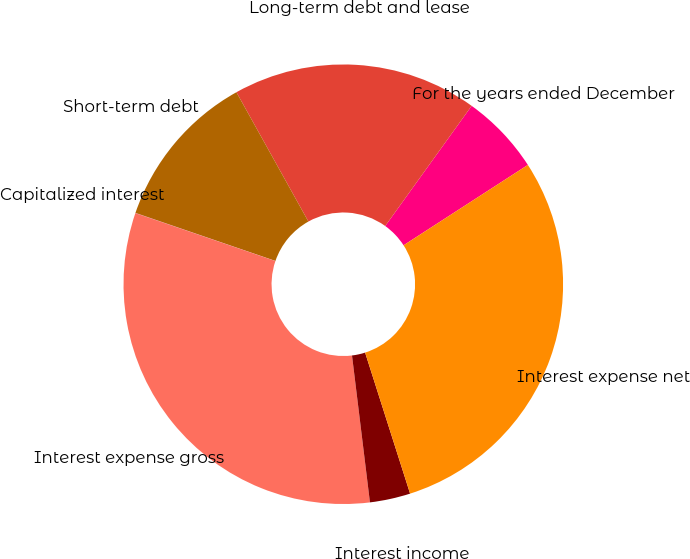<chart> <loc_0><loc_0><loc_500><loc_500><pie_chart><fcel>For the years ended December<fcel>Long-term debt and lease<fcel>Short-term debt<fcel>Capitalized interest<fcel>Interest expense gross<fcel>Interest income<fcel>Interest expense net<nl><fcel>5.94%<fcel>18.01%<fcel>11.65%<fcel>0.02%<fcel>32.18%<fcel>2.98%<fcel>29.22%<nl></chart> 